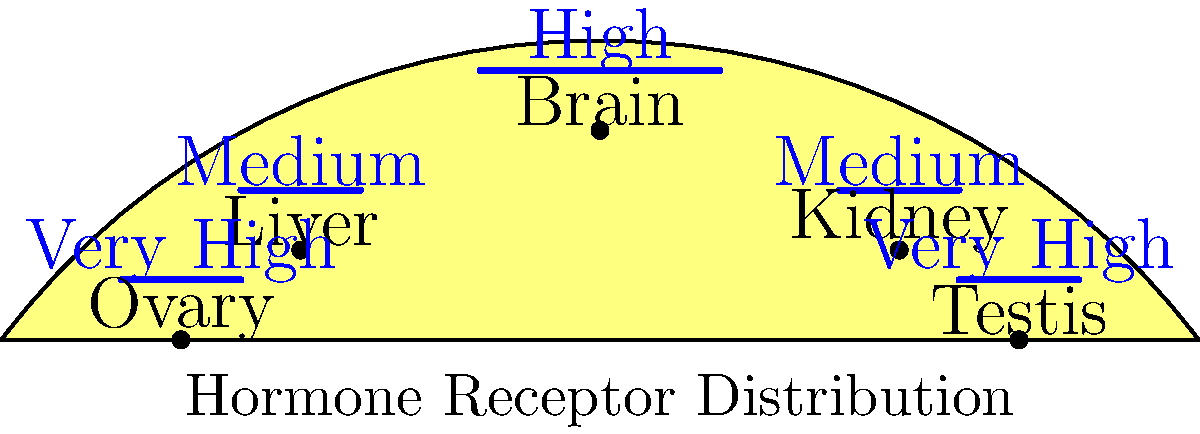Based on the cross-sectional diagram showing hormone receptor distribution across different organs, which organ(s) exhibit the highest concentration of receptors, and how might this impact the design of hormone manipulation experiments? To answer this question, we need to analyze the diagram and consider the implications for hormone manipulation experiments:

1. Examine the receptor distribution labels:
   - Brain: High
   - Liver: Medium
   - Kidney: Medium
   - Ovary: Very High
   - Testis: Very High

2. Identify the organs with the highest concentration:
   The ovaries and testes show "Very High" receptor concentrations.

3. Consider the impact on hormone manipulation experiments:
   a) Target specificity: Experiments targeting these organs may require lower hormone doses due to their high receptor density.
   b) Sensitivity: These organs will likely be more responsive to hormone manipulations.
   c) Side effects: Manipulations targeting other organs may have strong effects on reproductive functions due to the high receptor density in gonads.
   d) Feedback mechanisms: Changes in gonadal hormone levels may have significant impacts on the hypothalamic-pituitary-gonadal axis.
   e) Experimental design: Researchers may need to account for potential confounding effects on reproductive function when manipulating hormones for other purposes.

4. Implications for experimental design:
   - Use of gonad-specific hormone analogs or antagonists
   - Consideration of gonadectomy in some experiments to isolate effects on other organs
   - Careful monitoring of reproductive parameters in long-term hormone manipulation studies
Answer: Ovaries and testes; highest sensitivity to hormones, requiring careful dosing and consideration of reproductive effects in experiments. 